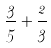Convert formula to latex. <formula><loc_0><loc_0><loc_500><loc_500>\frac { 3 } { 5 } + \frac { 2 } { 3 }</formula> 